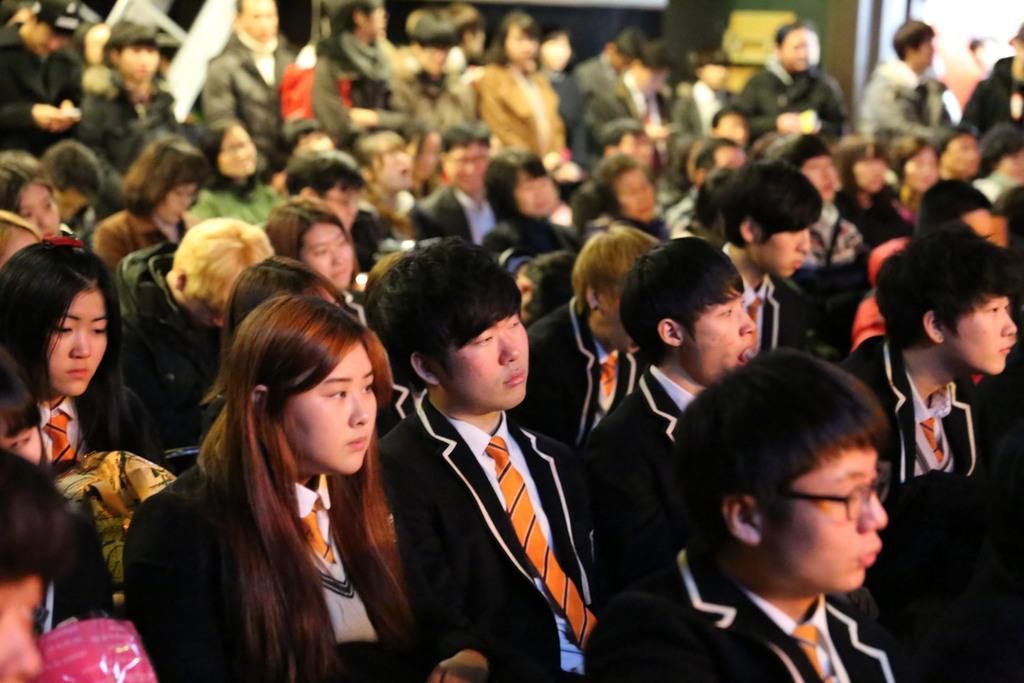Please provide a concise description of this image. In the foreground of this image, there are group of people sitting and at the top, few are standing. 